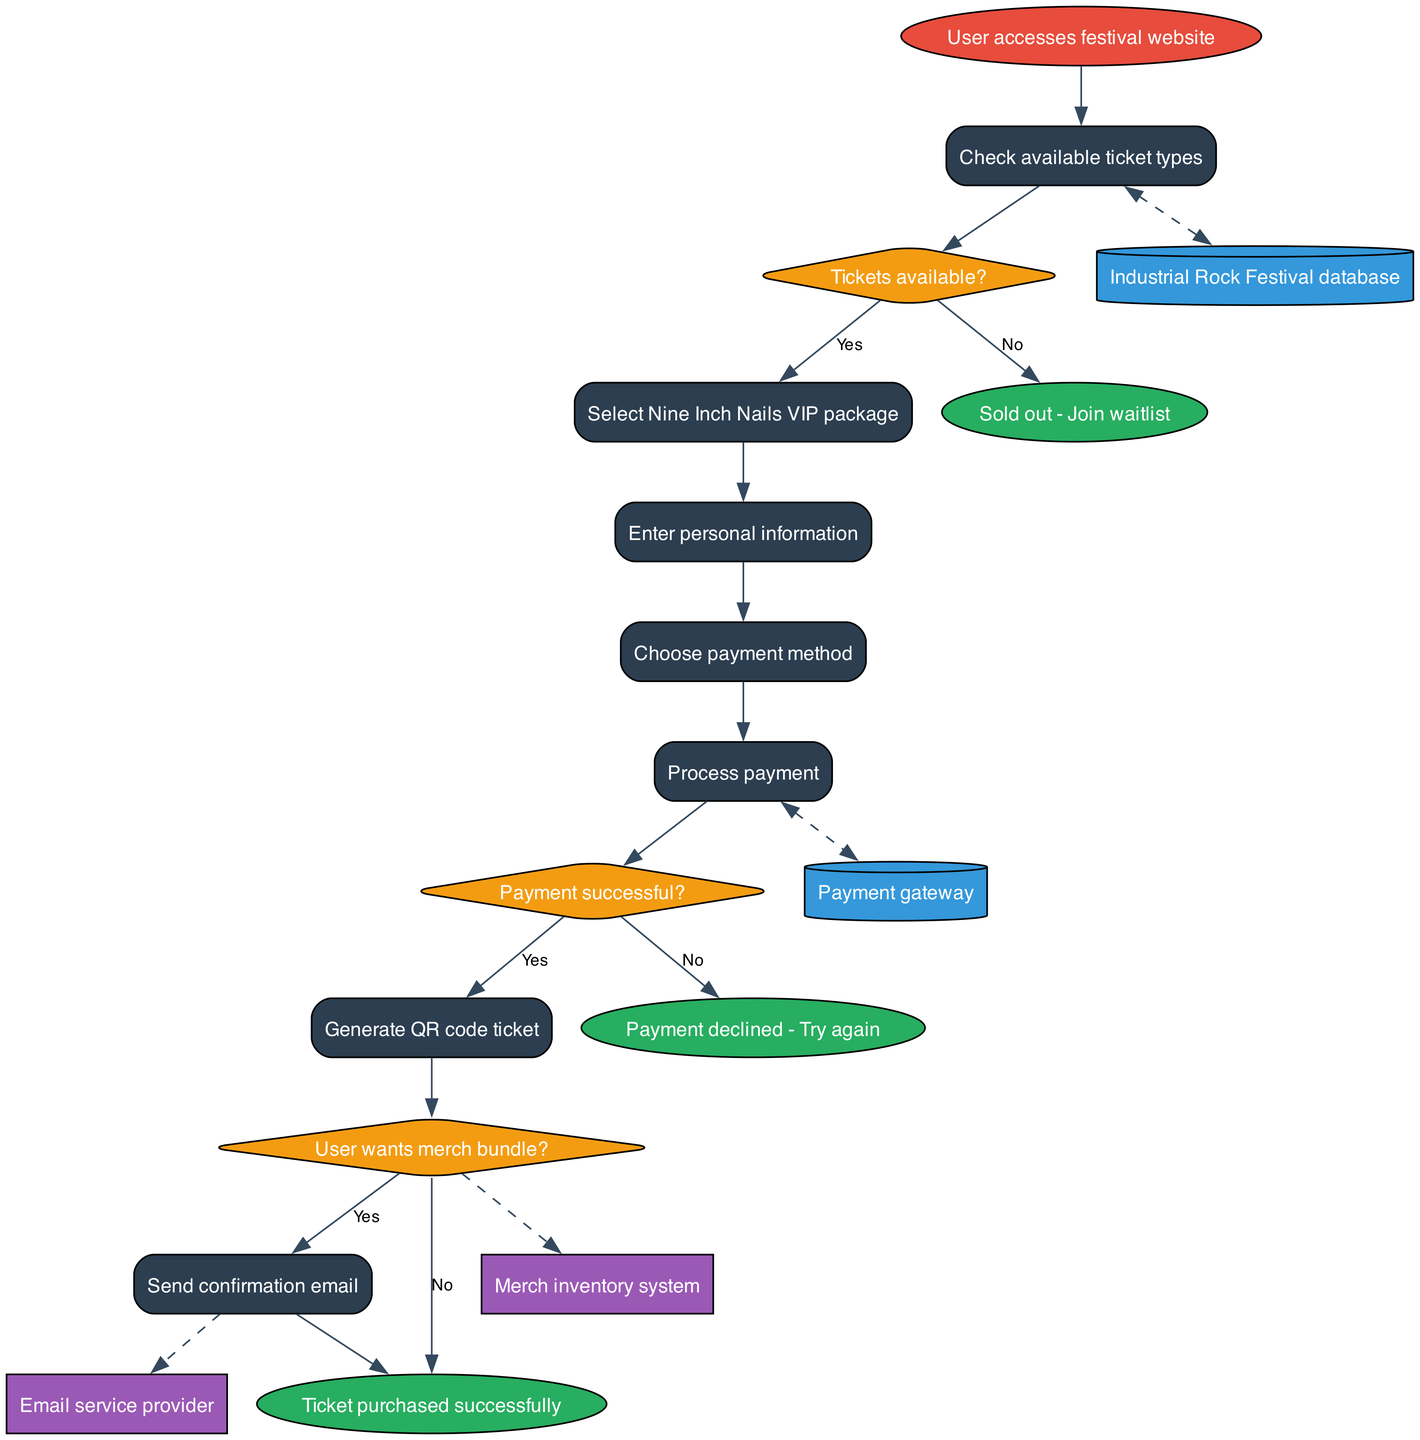What is the start node of the diagram? The start node indicates where the process begins. In this case, it states “User accesses festival website,” which clearly defines the first action in the flowchart.
Answer: User accesses festival website How many processes are there in total? The diagram lists several actions that constitute processes, specifically seven unique processes related to ticketing. These include checking tickets, payment processing, and generating QR codes.
Answer: 7 What is the first decision point in the flowchart? The first decision is indicative of whether tickets are available, placed immediately after the initial process of checking available ticket types. This decision point is crucial for determining the next steps in ticket purchase.
Answer: Tickets available? Which endpoint corresponds to payment being declined? The endpoint that follows if a payment is not successful is labeled “Payment declined - Try again.” This endpoint highlights a failure point in the process flow, directing the user on what to do next.
Answer: Payment declined - Try again What happens if the user selects 'Yes' for wanting a merch bundle? If the user expresses interest in a merch bundle and selects 'Yes', the flow continues from the decision point related to merch bundles, leading to the process of sending a confirmation email after generating the ticket.
Answer: Send confirmation email How many external entities are represented in the diagram? The diagram includes two external entities listed, which are essential for the functioning of the ticketing system: an “Email service provider” and a “Merch inventory system.” Both are involved in the overall process of ticket handling and merchandise fulfillment.
Answer: 2 What is the relationship between the payment process and the payment gateway? The edge in the diagram indicates that after processing the payment, there is a bi-directional interaction with the “Payment gateway,” suggesting that the ticketing system sends data to and receives confirmations from the payment gateway for transaction verification.
Answer: dashed Which process comes after entering personal information? Following the action of entering personal information, the next step is characterized by choosing a payment method. This indicates the progression toward finalizing the purchasing process after providing personal details.
Answer: Choose payment method 